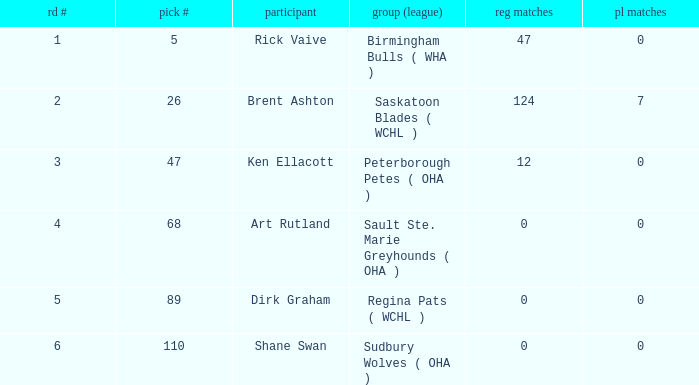How many reg GP for rick vaive in round 1? None. 